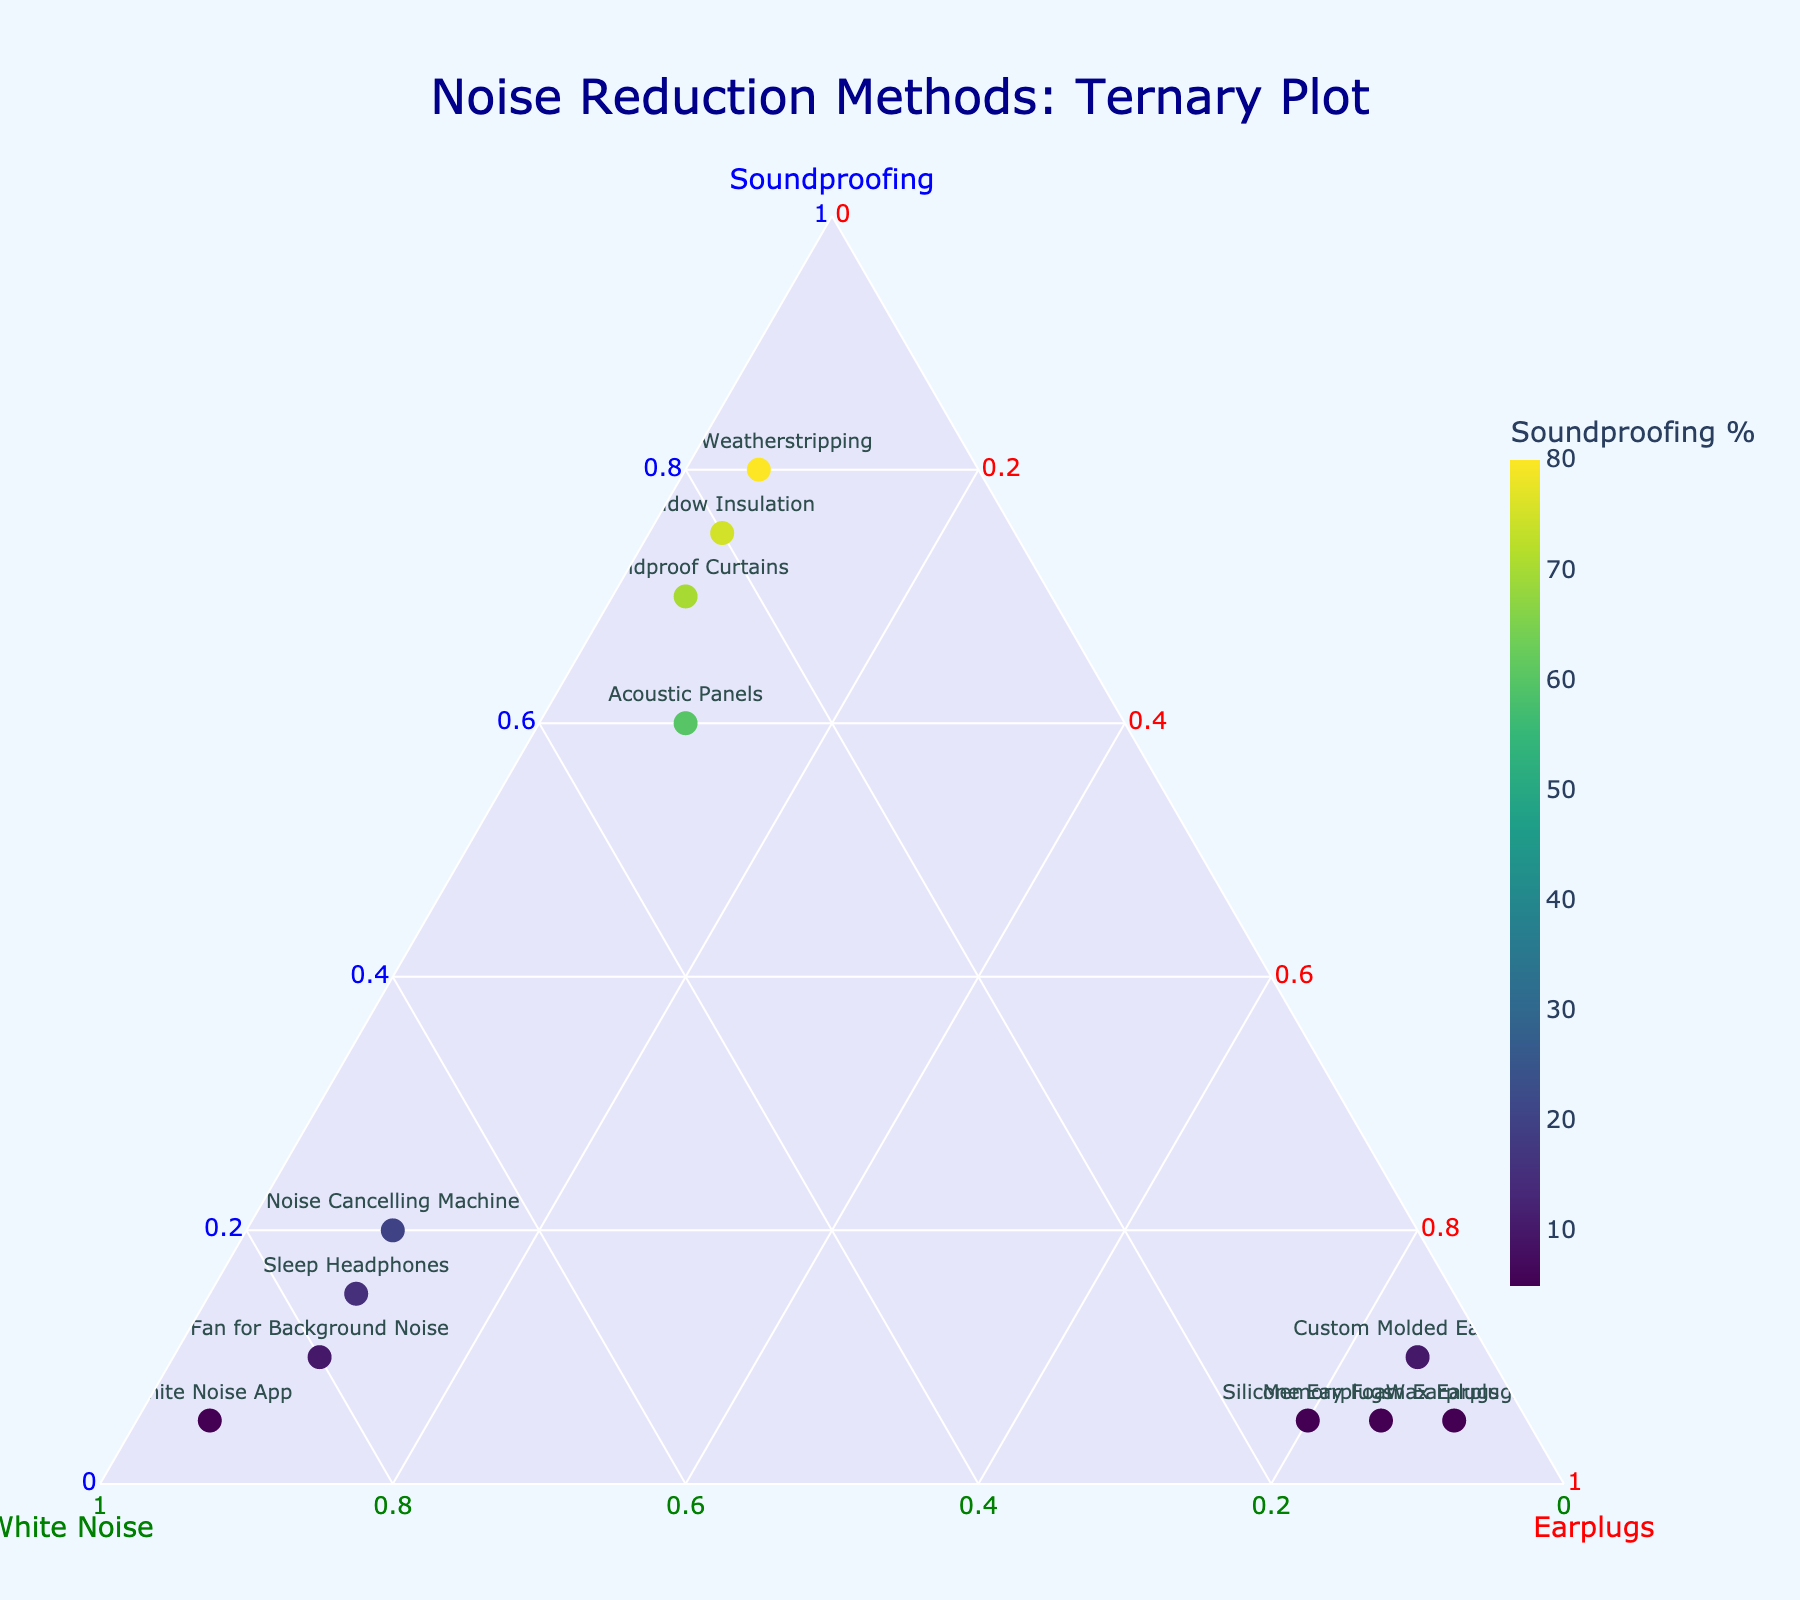Which noise reduction method has the highest percentage of soundproofing? From the ternary plot, the highest point on the soundproofing axis indicates 'Door Weatherstripping' with 80%.
Answer: Door Weatherstripping Which method relies the most on white noise? By examining the ternary plot, 'White Noise App' has the highest percentage of white noise at 90%.
Answer: White Noise App Which method predominantly uses earplugs? Looking at the ternary plot, 'Wax Earplugs' has the highest percentage value for earplugs at 90%.
Answer: Wax Earplugs How many methods have a soundproofing percentage higher than 70%? Methods above 70% on the soundproofing axis are 'Window Insulation', 'Soundproof Curtains', and 'Door Weatherstripping', making the total 3.
Answer: 3 Which method has the most balanced distribution among soundproofing, white noise, and earplugs? 'Acoustic Panels' shows the most balanced distribution with 60% soundproofing, 30% white noise, and 10% earplugs.
Answer: Acoustic Panels Which method has the second highest value for white noise? The second highest value for white noise after 'White Noise App' (90%) is 'Fan for Background Noise' at 80%.
Answer: Fan for Background Noise Which method uses a combination of around 75% white noise and 10% earplugs? 'Sleep Headphones' has 75% white noise and 10% earplugs as observed in the ternary plot.
Answer: Sleep Headphones Compare the use of soundproofing in 'Acoustic Panels' and 'Noise Cancelling Machine'. 'Acoustic Panels' use 60% soundproofing while 'Noise Cancelling Machine' uses 20% soundproofing, showing 'Acoustic Panels' rely more heavily on soundproofing.
Answer: Acoustic Panels What is the percentage of methods relying mostly on earplugs? Methods predominantly using earplugs (>80%) are 'Silicone Earplugs', 'Memory Foam Earplugs', 'Wax Earplugs', and 'Custom Molded Earplugs', totaling 4 methods.
Answer: 4 If combining the highest values of each method, what percentage would we get for soundproofing, white noise, and earplugs? Adding highest values: 80% for soundproofing (Door Weatherstripping), 90% for white noise (White Noise App), and 90% for earplugs (Wax Earplugs) gives 260%.
Answer: 260% 